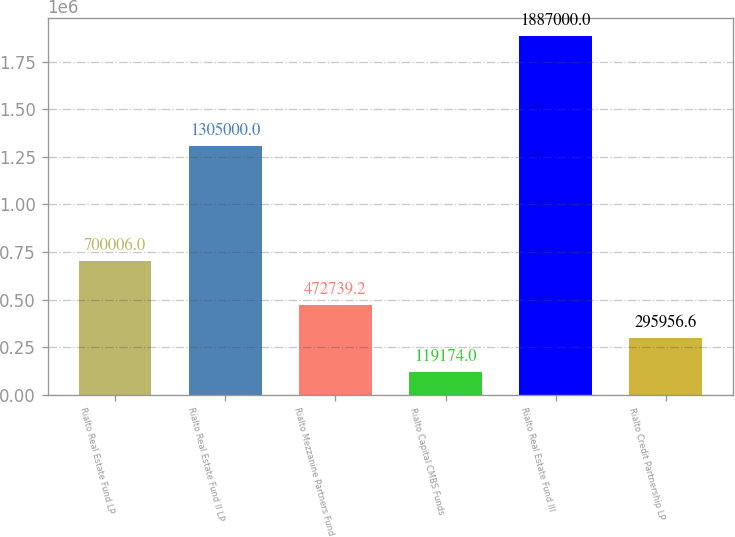Convert chart. <chart><loc_0><loc_0><loc_500><loc_500><bar_chart><fcel>Rialto Real Estate Fund LP<fcel>Rialto Real Estate Fund II LP<fcel>Rialto Mezzanine Partners Fund<fcel>Rialto Capital CMBS Funds<fcel>Rialto Real Estate Fund III<fcel>Rialto Credit Partnership LP<nl><fcel>700006<fcel>1.305e+06<fcel>472739<fcel>119174<fcel>1.887e+06<fcel>295957<nl></chart> 